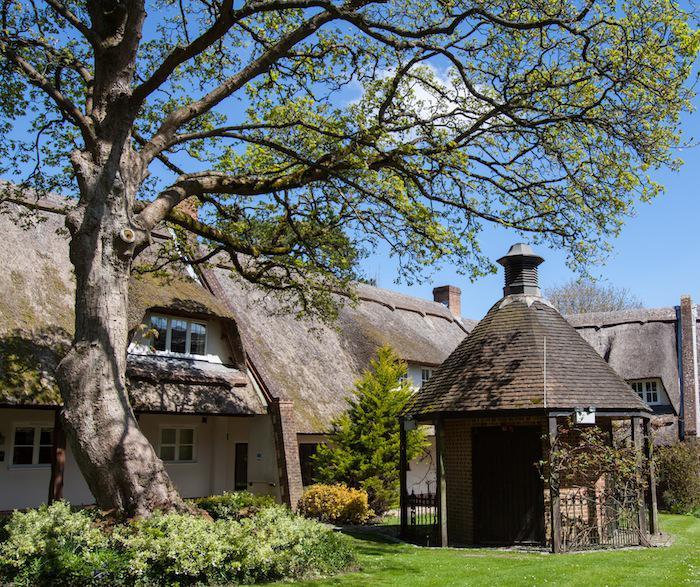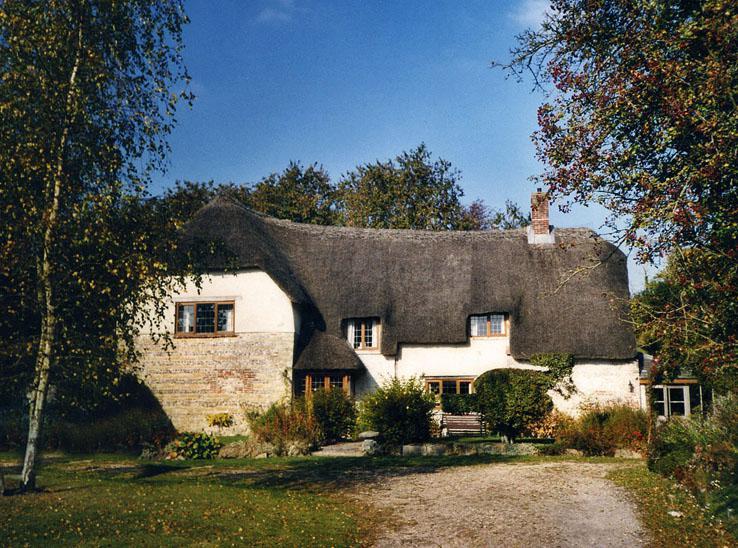The first image is the image on the left, the second image is the image on the right. For the images displayed, is the sentence "The right image is a head-on view of a white building with at least two notches in the roofline to accommodate upper story windows and at least one pyramid roof shape projecting at the front of the house." factually correct? Answer yes or no. Yes. 